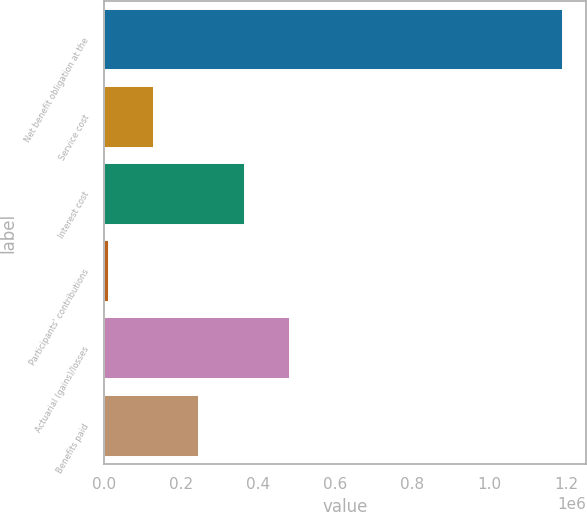Convert chart. <chart><loc_0><loc_0><loc_500><loc_500><bar_chart><fcel>Net benefit obligation at the<fcel>Service cost<fcel>Interest cost<fcel>Participants' contributions<fcel>Actuarial (gains)/losses<fcel>Benefits paid<nl><fcel>1.19134e+06<fcel>129587<fcel>365533<fcel>11614<fcel>483506<fcel>247560<nl></chart> 